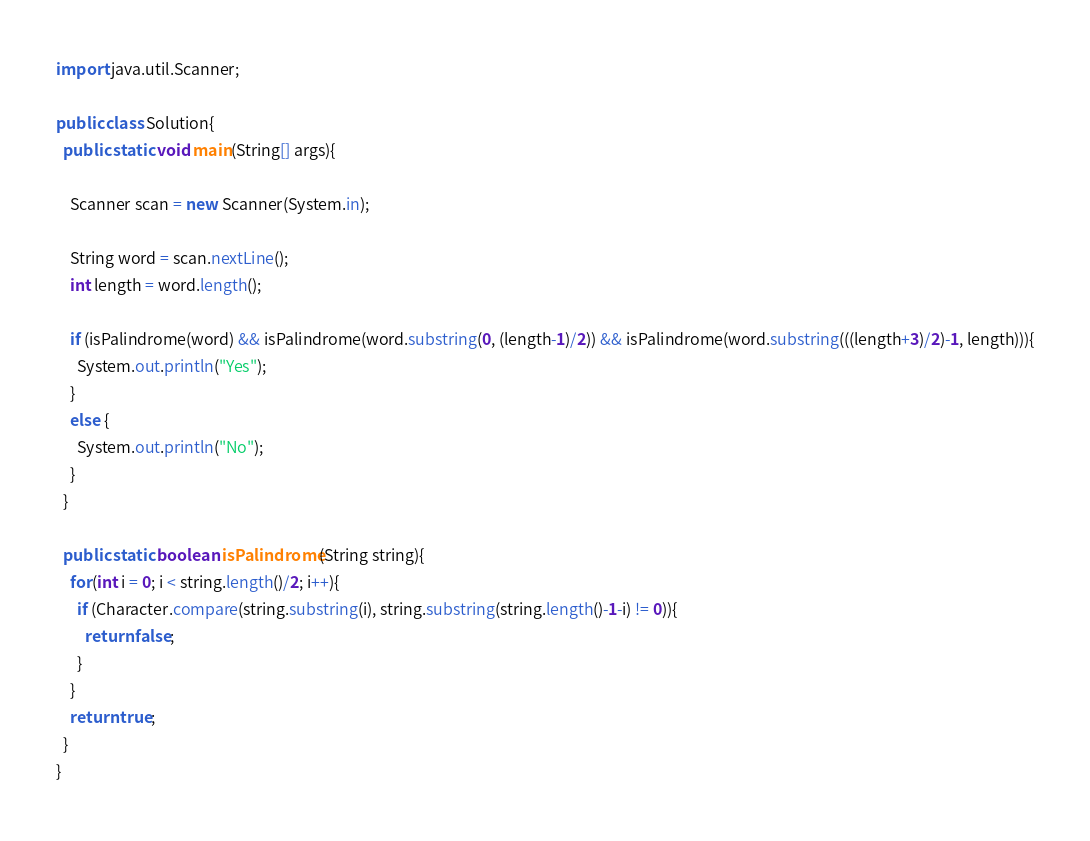Convert code to text. <code><loc_0><loc_0><loc_500><loc_500><_Java_>import java.util.Scanner;

public class Solution{
  public static void main(String[] args){

    Scanner scan = new Scanner(System.in);

    String word = scan.nextLine();
    int length = word.length();

    if (isPalindrome(word) && isPalindrome(word.substring(0, (length-1)/2)) && isPalindrome(word.substring(((length+3)/2)-1, length))){
      System.out.println("Yes");
    }
    else {
      System.out.println("No");
    }
  }

  public static boolean isPalindrome(String string){
    for(int i = 0; i < string.length()/2; i++){
      if (Character.compare(string.substring(i), string.substring(string.length()-1-i) != 0)){
        return false;
      }
    }
    return true;
  }
}</code> 